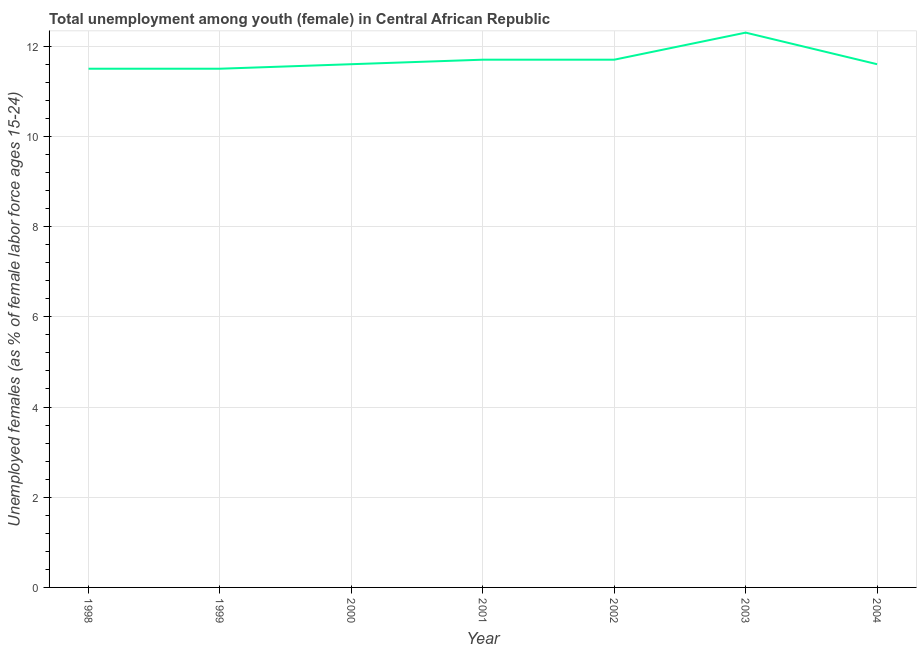What is the unemployed female youth population in 2001?
Your answer should be compact. 11.7. Across all years, what is the maximum unemployed female youth population?
Offer a terse response. 12.3. Across all years, what is the minimum unemployed female youth population?
Provide a succinct answer. 11.5. What is the sum of the unemployed female youth population?
Your answer should be very brief. 81.9. What is the difference between the unemployed female youth population in 1998 and 2003?
Your response must be concise. -0.8. What is the average unemployed female youth population per year?
Your response must be concise. 11.7. What is the median unemployed female youth population?
Offer a terse response. 11.6. Do a majority of the years between 2004 and 2002 (inclusive) have unemployed female youth population greater than 8 %?
Give a very brief answer. No. Is the difference between the unemployed female youth population in 1999 and 2001 greater than the difference between any two years?
Provide a succinct answer. No. What is the difference between the highest and the second highest unemployed female youth population?
Your response must be concise. 0.6. What is the difference between the highest and the lowest unemployed female youth population?
Your response must be concise. 0.8. Does the unemployed female youth population monotonically increase over the years?
Offer a terse response. No. How many lines are there?
Provide a succinct answer. 1. What is the difference between two consecutive major ticks on the Y-axis?
Your response must be concise. 2. Does the graph contain grids?
Offer a terse response. Yes. What is the title of the graph?
Offer a very short reply. Total unemployment among youth (female) in Central African Republic. What is the label or title of the Y-axis?
Your answer should be very brief. Unemployed females (as % of female labor force ages 15-24). What is the Unemployed females (as % of female labor force ages 15-24) of 2000?
Make the answer very short. 11.6. What is the Unemployed females (as % of female labor force ages 15-24) of 2001?
Your answer should be very brief. 11.7. What is the Unemployed females (as % of female labor force ages 15-24) in 2002?
Keep it short and to the point. 11.7. What is the Unemployed females (as % of female labor force ages 15-24) in 2003?
Your answer should be very brief. 12.3. What is the Unemployed females (as % of female labor force ages 15-24) in 2004?
Make the answer very short. 11.6. What is the difference between the Unemployed females (as % of female labor force ages 15-24) in 1998 and 2000?
Keep it short and to the point. -0.1. What is the difference between the Unemployed females (as % of female labor force ages 15-24) in 1998 and 2004?
Make the answer very short. -0.1. What is the difference between the Unemployed females (as % of female labor force ages 15-24) in 1999 and 2000?
Offer a terse response. -0.1. What is the difference between the Unemployed females (as % of female labor force ages 15-24) in 1999 and 2002?
Provide a short and direct response. -0.2. What is the difference between the Unemployed females (as % of female labor force ages 15-24) in 1999 and 2003?
Your answer should be compact. -0.8. What is the difference between the Unemployed females (as % of female labor force ages 15-24) in 2000 and 2001?
Give a very brief answer. -0.1. What is the difference between the Unemployed females (as % of female labor force ages 15-24) in 2000 and 2004?
Your answer should be compact. 0. What is the difference between the Unemployed females (as % of female labor force ages 15-24) in 2001 and 2004?
Provide a succinct answer. 0.1. What is the difference between the Unemployed females (as % of female labor force ages 15-24) in 2003 and 2004?
Make the answer very short. 0.7. What is the ratio of the Unemployed females (as % of female labor force ages 15-24) in 1998 to that in 2000?
Ensure brevity in your answer.  0.99. What is the ratio of the Unemployed females (as % of female labor force ages 15-24) in 1998 to that in 2001?
Keep it short and to the point. 0.98. What is the ratio of the Unemployed females (as % of female labor force ages 15-24) in 1998 to that in 2002?
Ensure brevity in your answer.  0.98. What is the ratio of the Unemployed females (as % of female labor force ages 15-24) in 1998 to that in 2003?
Offer a terse response. 0.94. What is the ratio of the Unemployed females (as % of female labor force ages 15-24) in 1999 to that in 2002?
Offer a very short reply. 0.98. What is the ratio of the Unemployed females (as % of female labor force ages 15-24) in 1999 to that in 2003?
Your response must be concise. 0.94. What is the ratio of the Unemployed females (as % of female labor force ages 15-24) in 2000 to that in 2001?
Give a very brief answer. 0.99. What is the ratio of the Unemployed females (as % of female labor force ages 15-24) in 2000 to that in 2003?
Make the answer very short. 0.94. What is the ratio of the Unemployed females (as % of female labor force ages 15-24) in 2001 to that in 2002?
Ensure brevity in your answer.  1. What is the ratio of the Unemployed females (as % of female labor force ages 15-24) in 2001 to that in 2003?
Make the answer very short. 0.95. What is the ratio of the Unemployed females (as % of female labor force ages 15-24) in 2002 to that in 2003?
Your answer should be very brief. 0.95. What is the ratio of the Unemployed females (as % of female labor force ages 15-24) in 2003 to that in 2004?
Provide a succinct answer. 1.06. 